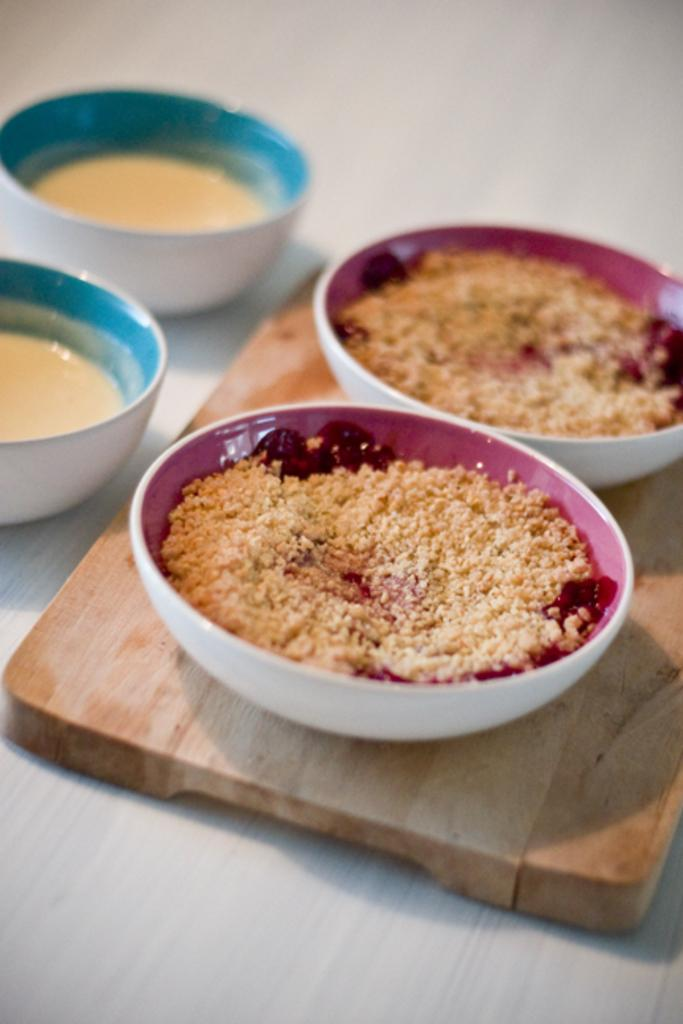What is in the two bowls that are visible in the image? There are two bowls with powder in the image. Where are the bowls located? The bowls are on a wooden block. What else can be seen on the table in the image? There are two soup bowls on a table. What type of metal is used to construct the prison in the image? There is no prison present in the image, so it is not possible to determine the type of metal used in its construction. 